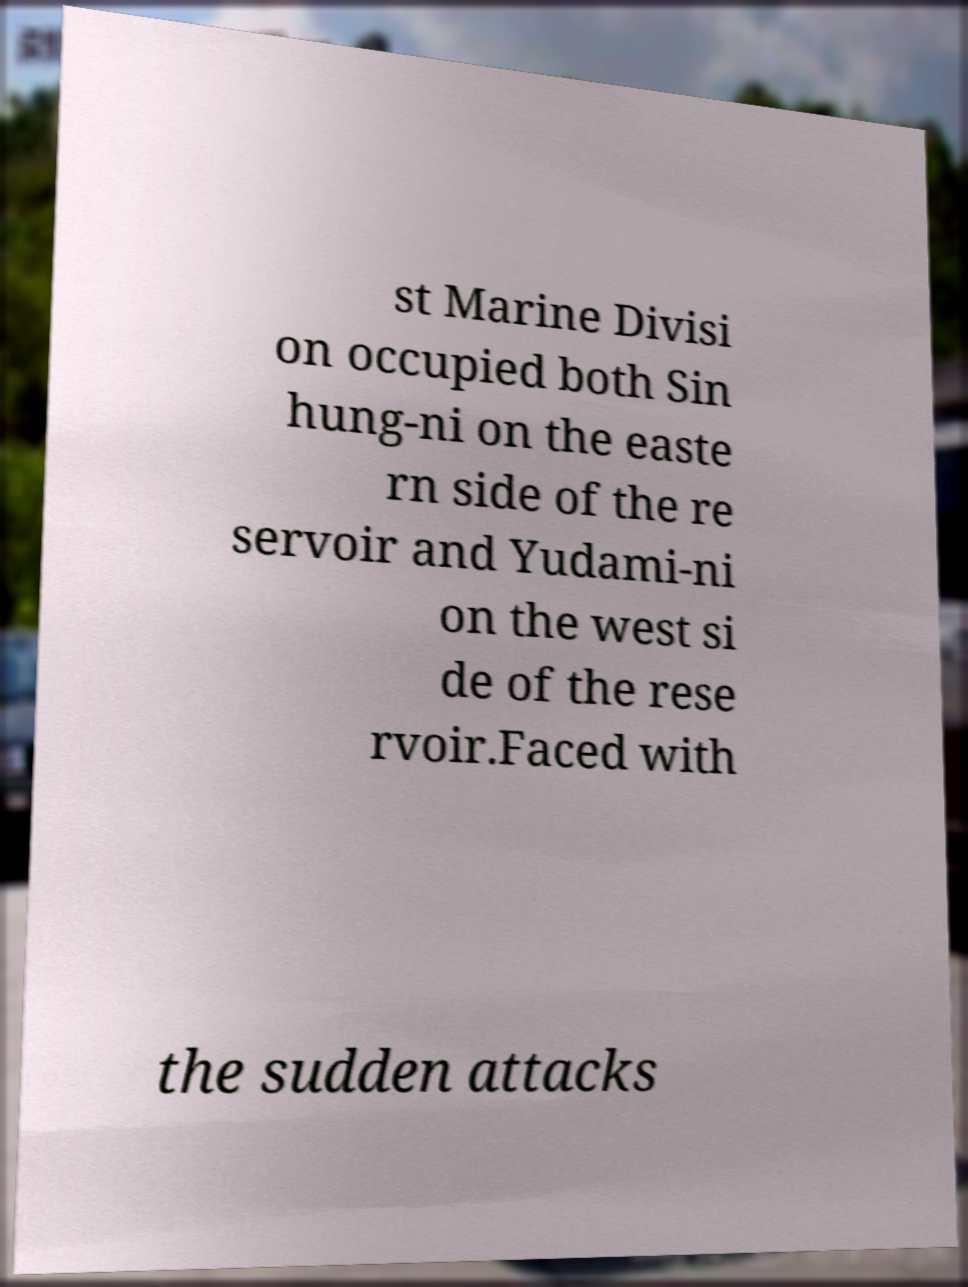Can you accurately transcribe the text from the provided image for me? st Marine Divisi on occupied both Sin hung-ni on the easte rn side of the re servoir and Yudami-ni on the west si de of the rese rvoir.Faced with the sudden attacks 